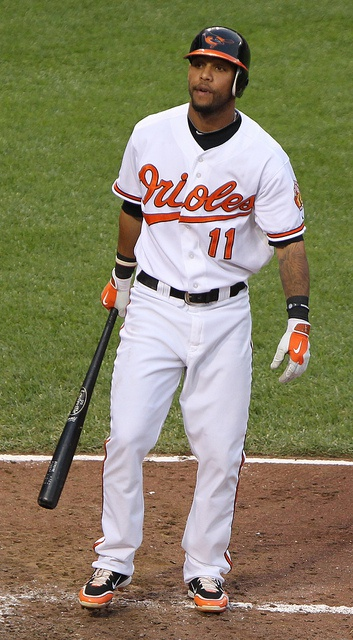Describe the objects in this image and their specific colors. I can see people in darkgreen, lavender, black, and darkgray tones, baseball bat in darkgreen, black, and gray tones, and baseball glove in darkgreen, lightgray, red, darkgray, and olive tones in this image. 